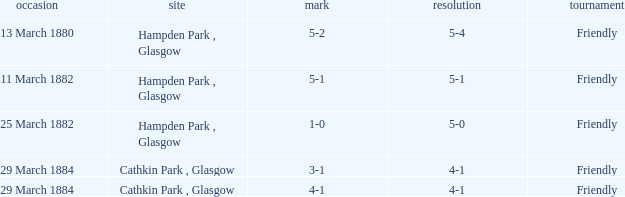Which item has a score of 5-1? 5-1. 